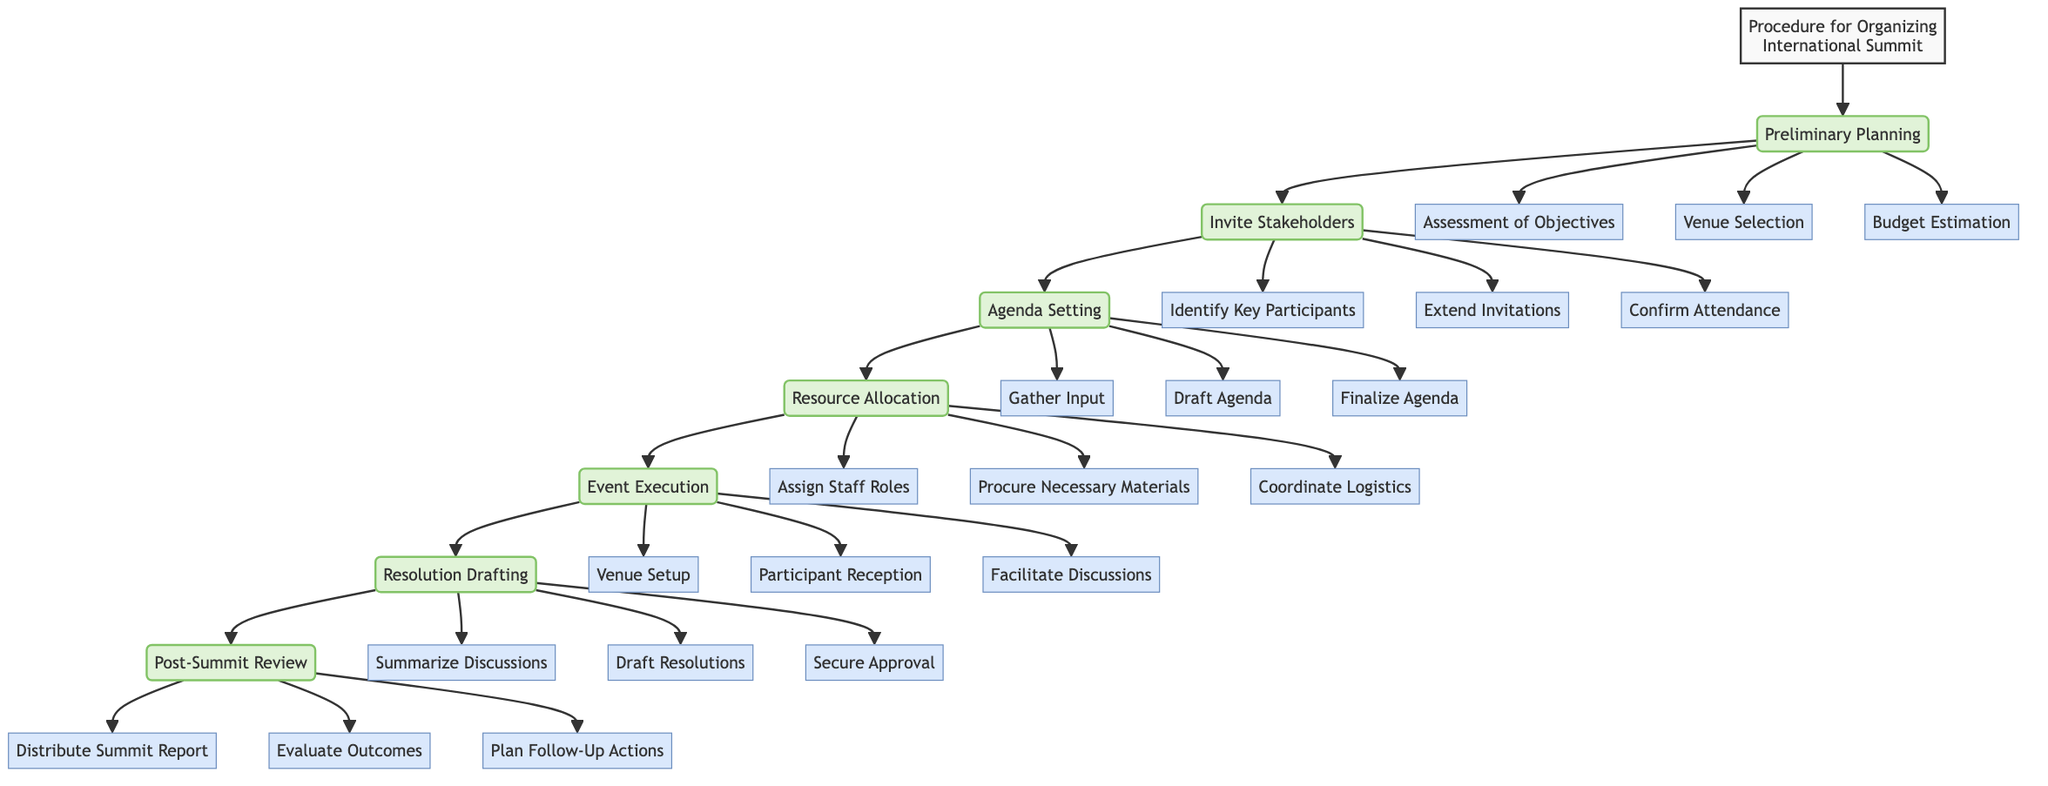What is the first step in organizing the summit? The diagram indicates that "Preliminary Planning" is the first step of the procedure for organizing the international summit.
Answer: Preliminary Planning How many main steps are there in the procedure? By counting the main steps shown in the diagram, there are seven primary steps involved in the procedure for organizing the summit.
Answer: 7 Which step involves assessing the summit's objectives? Within the "Preliminary Planning" step, there is a sub-step labeled "Assessment of Objectives" that focuses on determining the purpose and desired outcomes of the summit.
Answer: Assessment of Objectives What is the last step listed in the diagram? The final step of the procedure in the diagram is "Post-Summit Review," where evaluations and follow-up actions are conducted after the summit takes place.
Answer: Post-Summit Review What does the "Invite Stakeholders" step include? This step consists of three sub-steps: "Identify Key Participants," "Extend Invitations," and "Confirm Attendance," which together outline the process of engaging essential parties for the summit.
Answer: Identify Key Participants, Extend Invitations, Confirm Attendance Which step comes immediately after "Event Execution"? Following the "Event Execution" step, the procedure progresses to "Resolution Drafting," which involves documenting discussions and drafting resolutions based on the events that occurred during the summit.
Answer: Resolution Drafting How many sub-steps are included in "Resource Allocation"? The "Resource Allocation" step comprises three sub-steps: "Assign Staff Roles," "Procure Necessary Materials," and "Coordinate Logistics," totaling three sub-steps.
Answer: 3 What is the purpose of "Summarize Discussions" in the process? "Summarize Discussions" is a sub-step within "Resolution Drafting," aiming to document the key points and agreements reached during the summit discussions.
Answer: Document key points and agreements What action is taken in the "Post-Summit Review" phase? In the "Post-Summit Review" phase, one of the key actions is to "Evaluate Outcomes," where the organizers assess whether the summit's objectives were met and gather feedback.
Answer: Evaluate Outcomes 